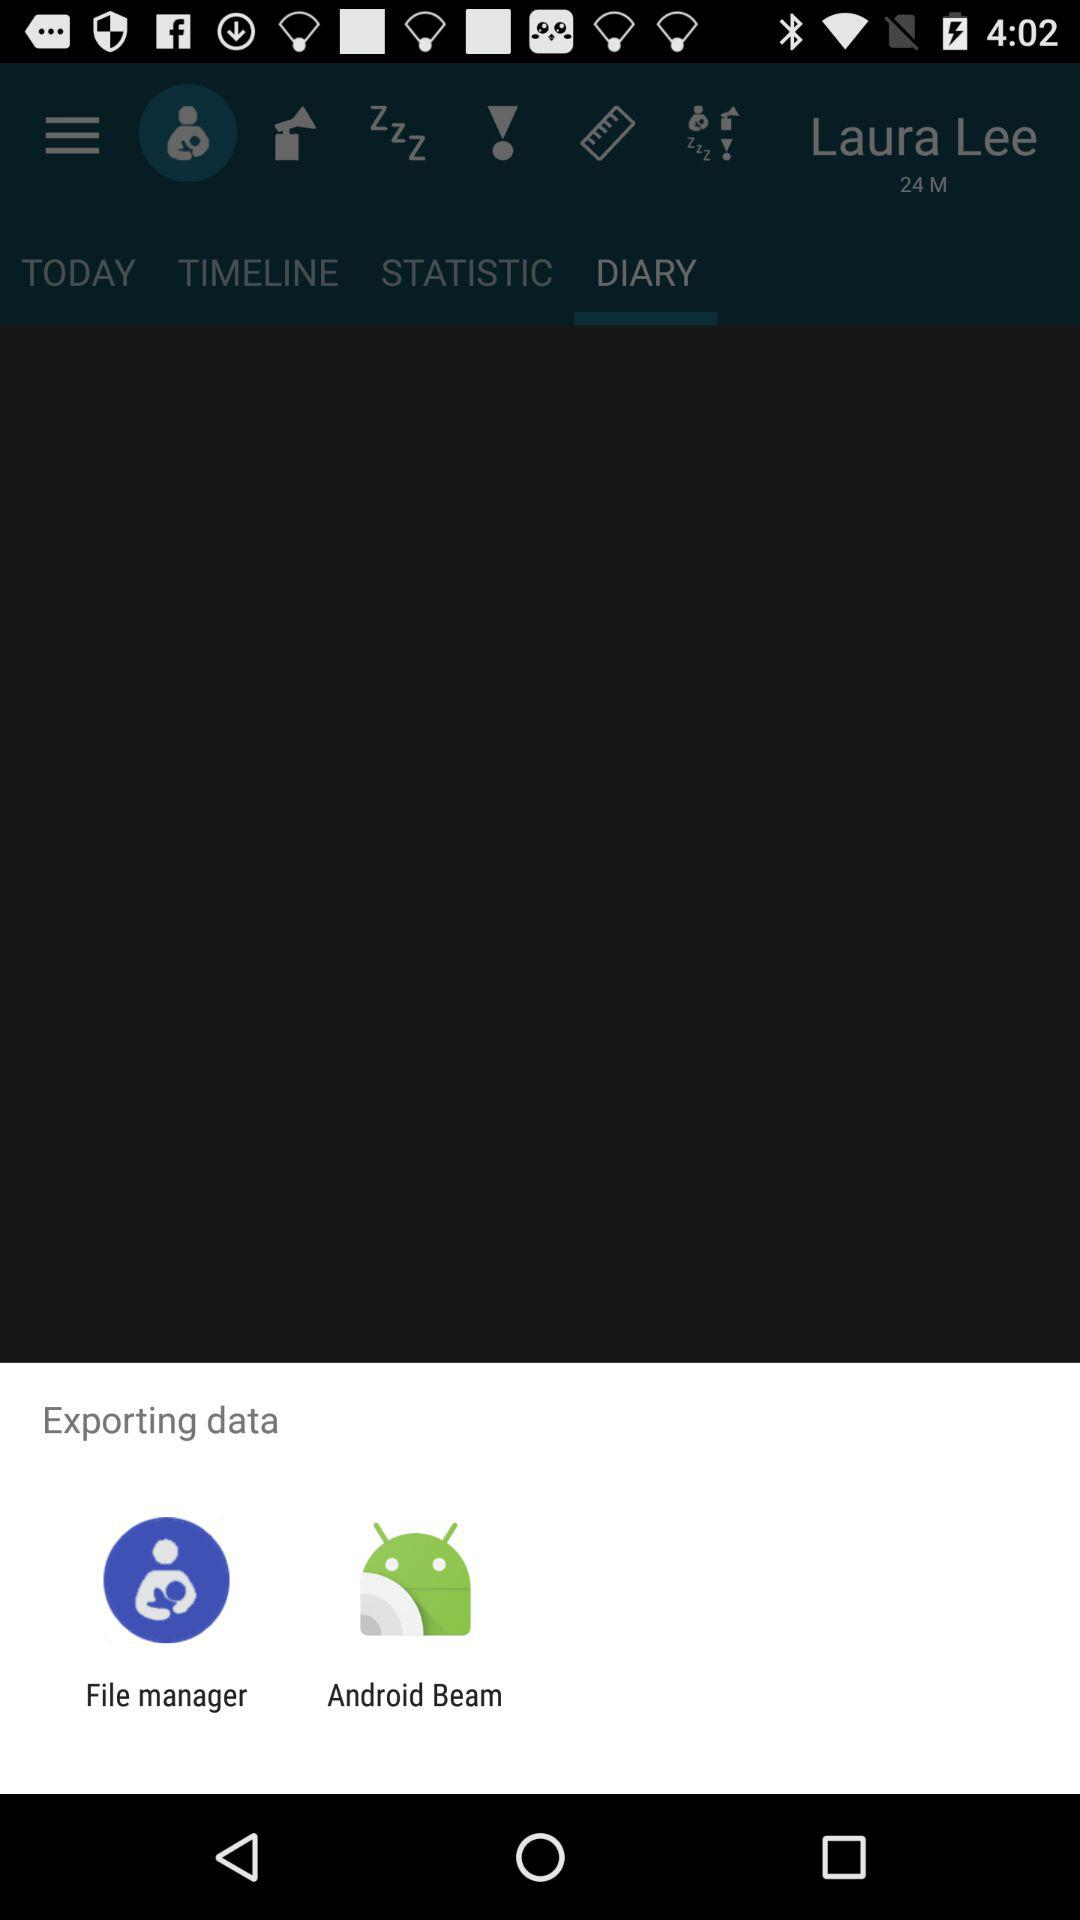What are the apps that can be used to export data? The apps are "File manager" and "Android Beam". 